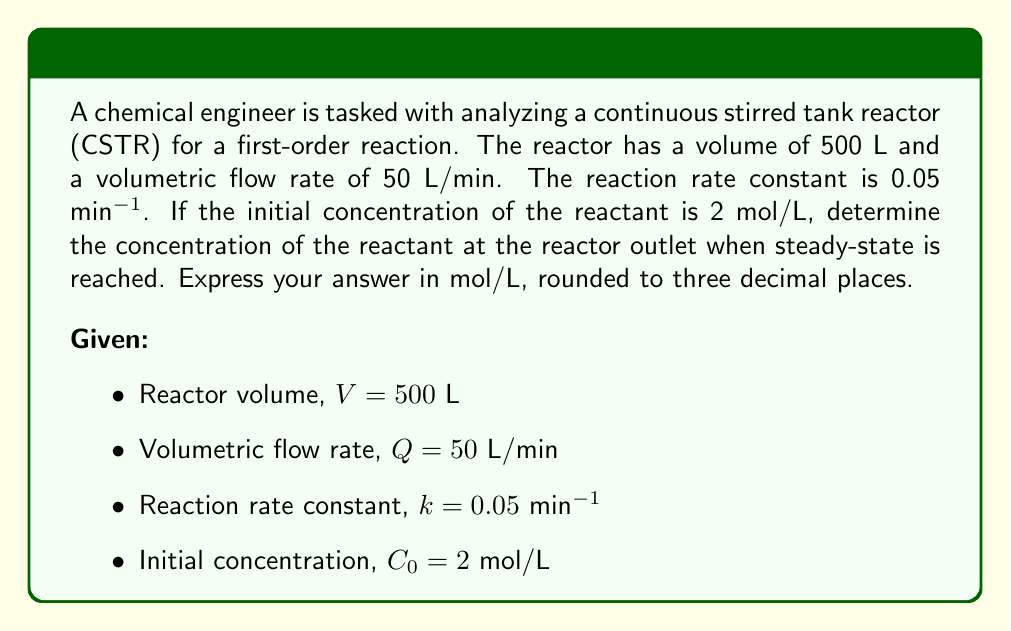Can you solve this math problem? To solve this problem, we'll use the material balance equation for a CSTR at steady-state. The steps are as follows:

1) The general material balance equation for a CSTR is:

   $$ \frac{dC}{dt} = \frac{Q}{V}(C_0 - C) - kC $$

2) At steady-state, $\frac{dC}{dt} = 0$, so the equation becomes:

   $$ 0 = \frac{Q}{V}(C_0 - C) - kC $$

3) Rearrange the equation:

   $$ \frac{Q}{V}C_0 = \frac{Q}{V}C + kC $$
   $$ \frac{Q}{V}C_0 = C(\frac{Q}{V} + k) $$

4) Solve for C:

   $$ C = \frac{\frac{Q}{V}C_0}{\frac{Q}{V} + k} $$

5) Calculate $\frac{Q}{V}$:

   $$ \frac{Q}{V} = \frac{50\text{ L/min}}{500\text{ L}} = 0.1\text{ min}^{-1} $$

6) Substitute the values into the equation:

   $$ C = \frac{0.1 \cdot 2}{0.1 + 0.05} = \frac{0.2}{0.15} $$

7) Calculate the final concentration:

   $$ C = 1.333\text{ mol/L} $$

8) Round to three decimal places:

   $$ C \approx 1.333\text{ mol/L} $$
Answer: $1.333$ mol/L 